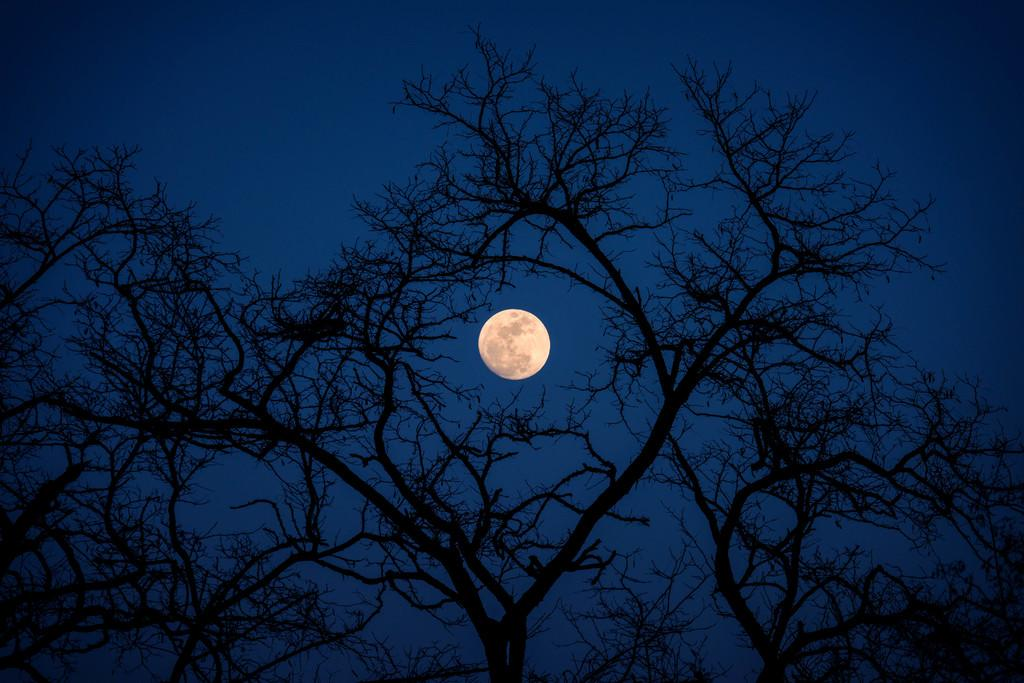What type of vegetation can be seen in the image? There are trees in the image. What celestial body is visible in the sky in the background of the image? The moon is visible in the sky in the background of the image. What type of sound can be heard coming from the stem in the image? There is no stem present in the image, and therefore no sound can be heard from it. 